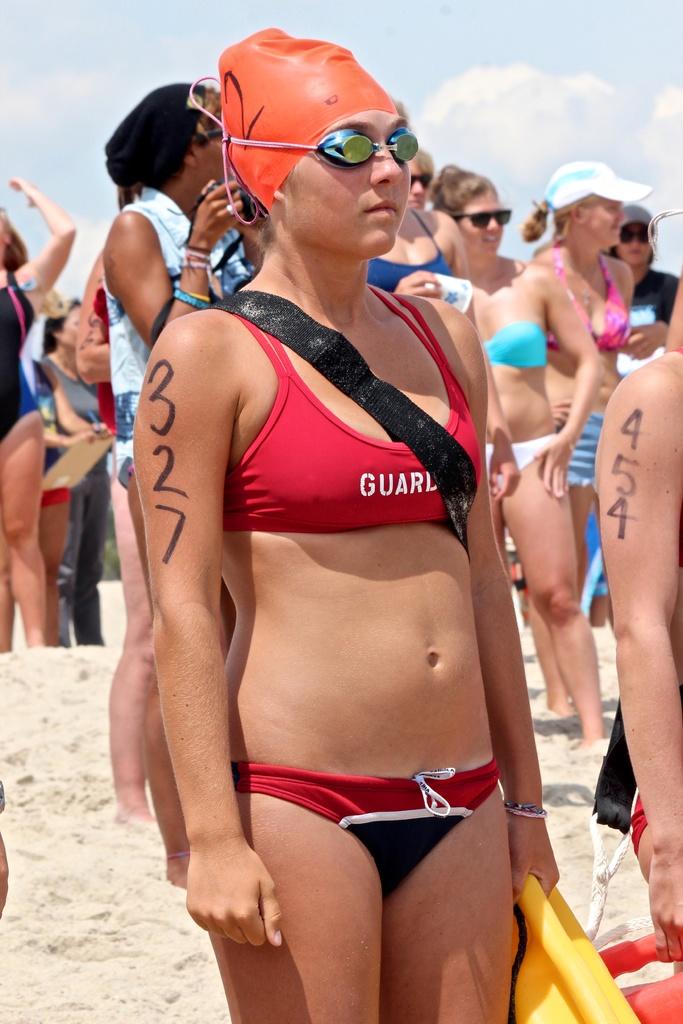What number is written on the guard's arm?
Provide a succinct answer. 327. 